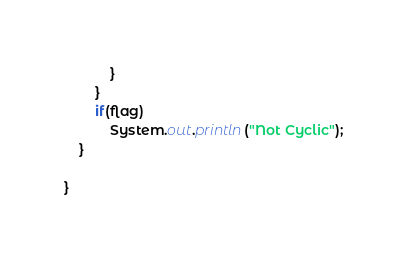<code> <loc_0><loc_0><loc_500><loc_500><_Java_>			}
		}
		if(flag)
			System.out.println("Not Cyclic");
	}

}
</code> 